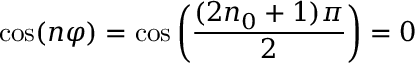Convert formula to latex. <formula><loc_0><loc_0><loc_500><loc_500>\cos ( n \varphi ) = \cos \left ( \frac { ( 2 n _ { 0 } + 1 ) \pi } { 2 } \right ) = 0</formula> 